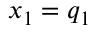<formula> <loc_0><loc_0><loc_500><loc_500>x _ { 1 } = q _ { 1 }</formula> 